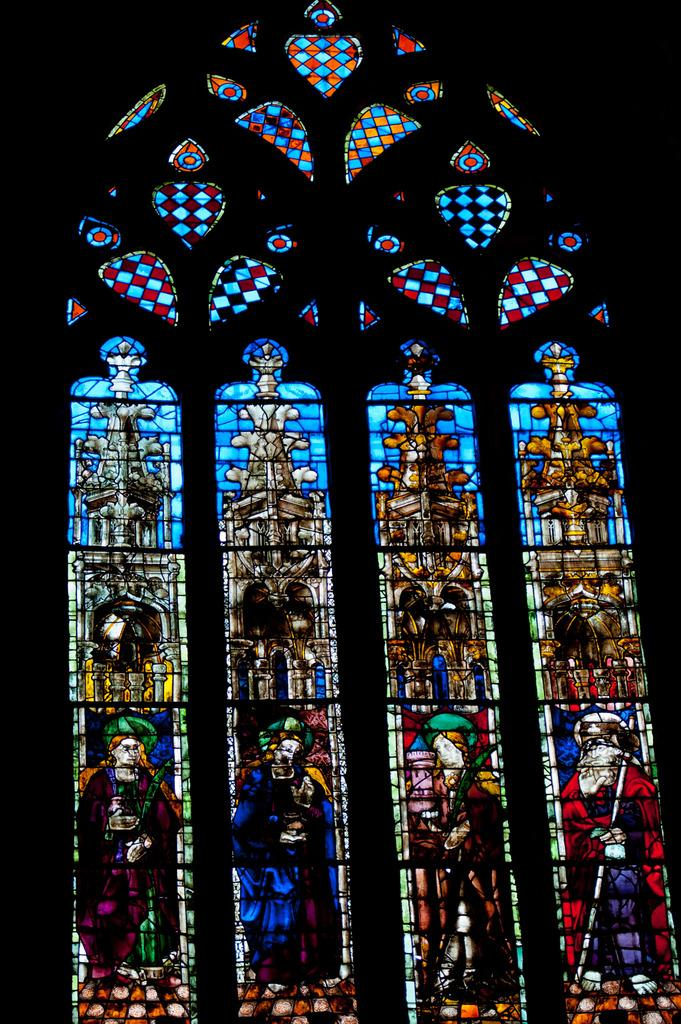What type of images can be seen in the picture? There are colorful design pictures in the image. What is the color of the background in the image? The background of the image is dark. What type of rod can be seen in the image? There is no rod present in the image. How many friends are visible in the image? There is no reference to friends in the image, as it only features colorful design pictures and a dark background. 